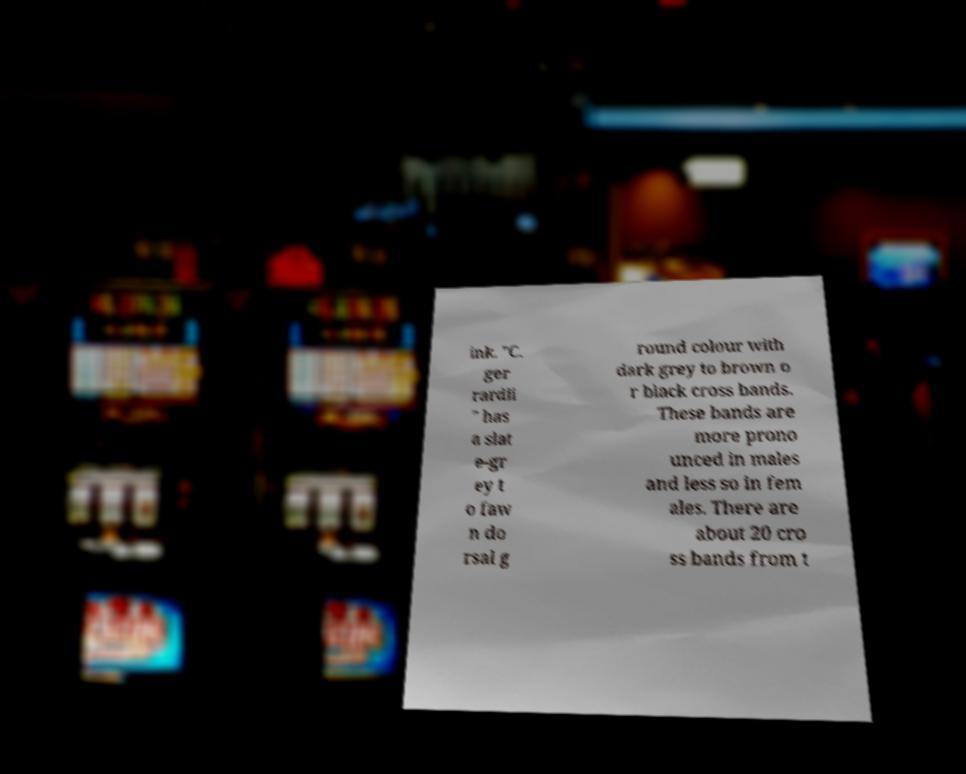Can you accurately transcribe the text from the provided image for me? ink. "C. ger rardii " has a slat e-gr ey t o faw n do rsal g round colour with dark grey to brown o r black cross bands. These bands are more prono unced in males and less so in fem ales. There are about 20 cro ss bands from t 